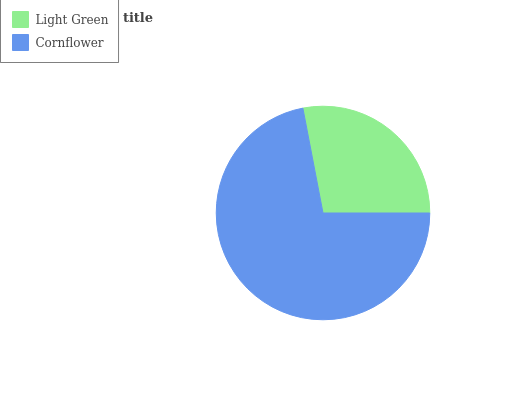Is Light Green the minimum?
Answer yes or no. Yes. Is Cornflower the maximum?
Answer yes or no. Yes. Is Cornflower the minimum?
Answer yes or no. No. Is Cornflower greater than Light Green?
Answer yes or no. Yes. Is Light Green less than Cornflower?
Answer yes or no. Yes. Is Light Green greater than Cornflower?
Answer yes or no. No. Is Cornflower less than Light Green?
Answer yes or no. No. Is Cornflower the high median?
Answer yes or no. Yes. Is Light Green the low median?
Answer yes or no. Yes. Is Light Green the high median?
Answer yes or no. No. Is Cornflower the low median?
Answer yes or no. No. 